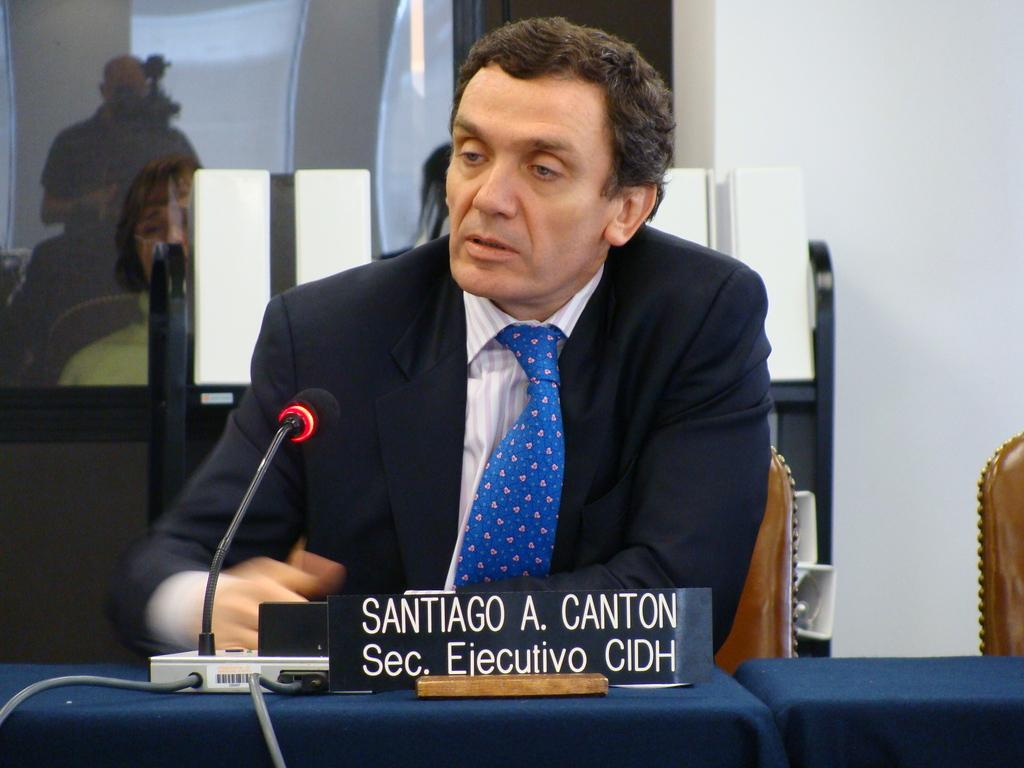What is the person in the image doing? The person is seated on a chair and speaking with a microphone in front of them. Can you describe the person's surroundings? There is a woman standing behind the person in the image. What might the person be using the microphone for? The person might be giving a speech, presenting, or hosting an event. What type of clover can be seen growing on the person's hair in the image? There is no clover visible in the image, nor is there any hair on the person's head. 